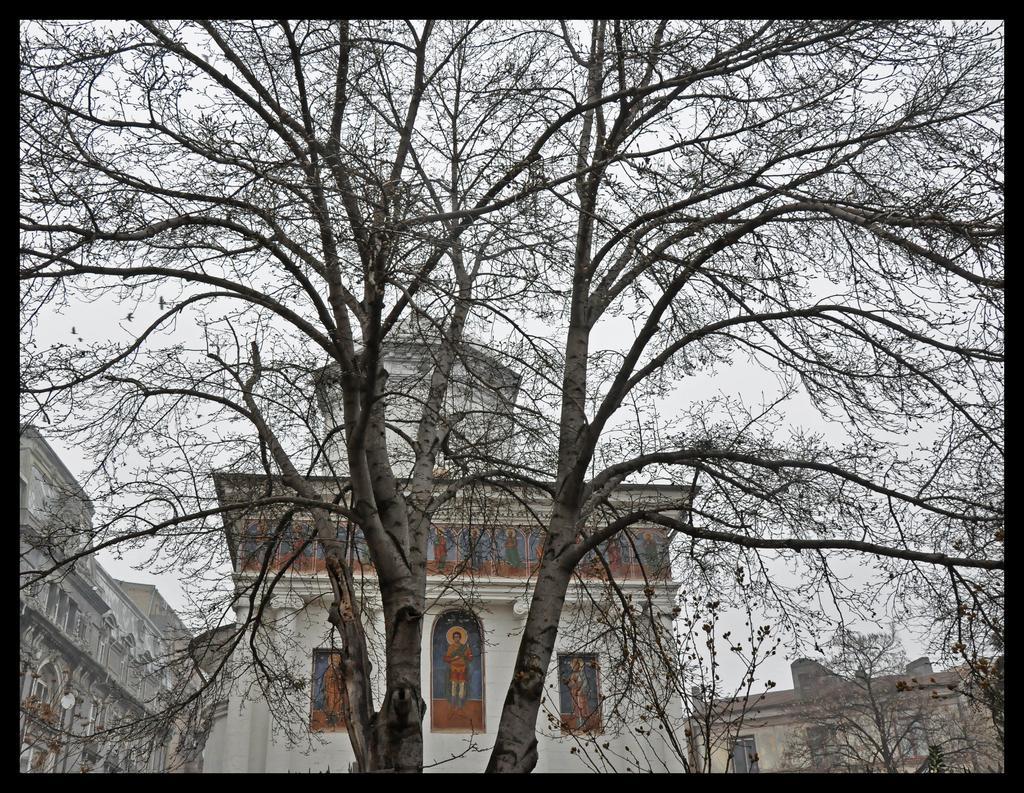How would you summarize this image in a sentence or two? In this picture, there is a tree. Behind the tree, there are buildings and a sky. 